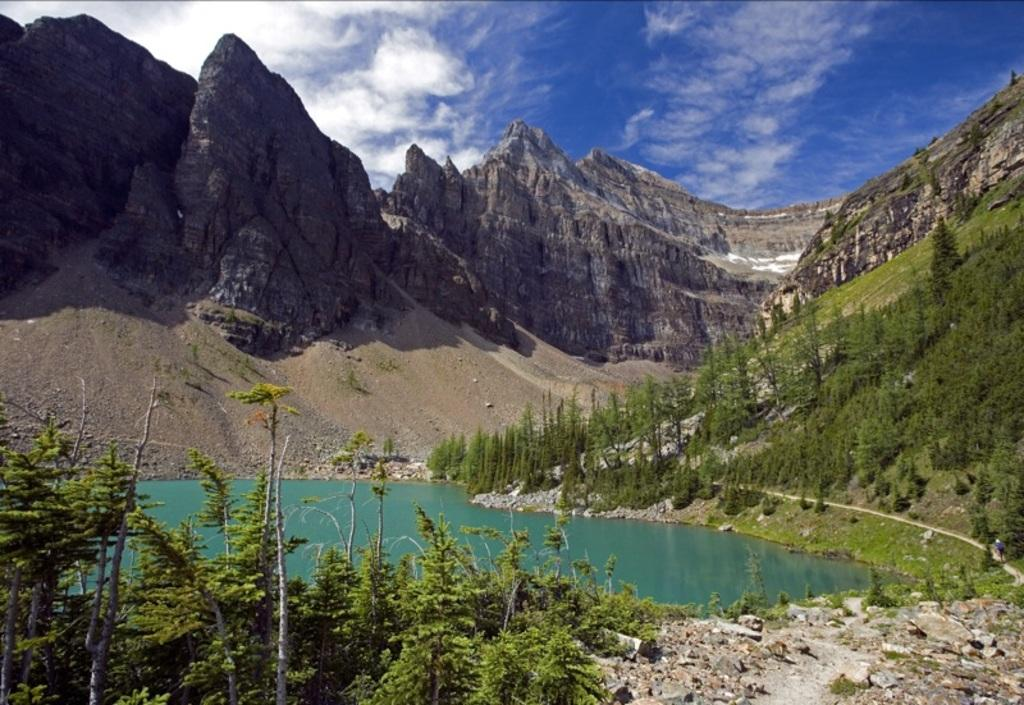What type of natural feature is present in the image? There is a lake in the image. What other geographical feature can be seen in the image? There is a hill in the image. What type of vegetation is visible around the lake? Trees are visible around the lake. What is visible at the top of the image? The sky is visible at the top of the image. How many passengers are on the committee in the image? There is no reference to passengers or a committee in the image; it features a lake, a hill, trees, and the sky. 